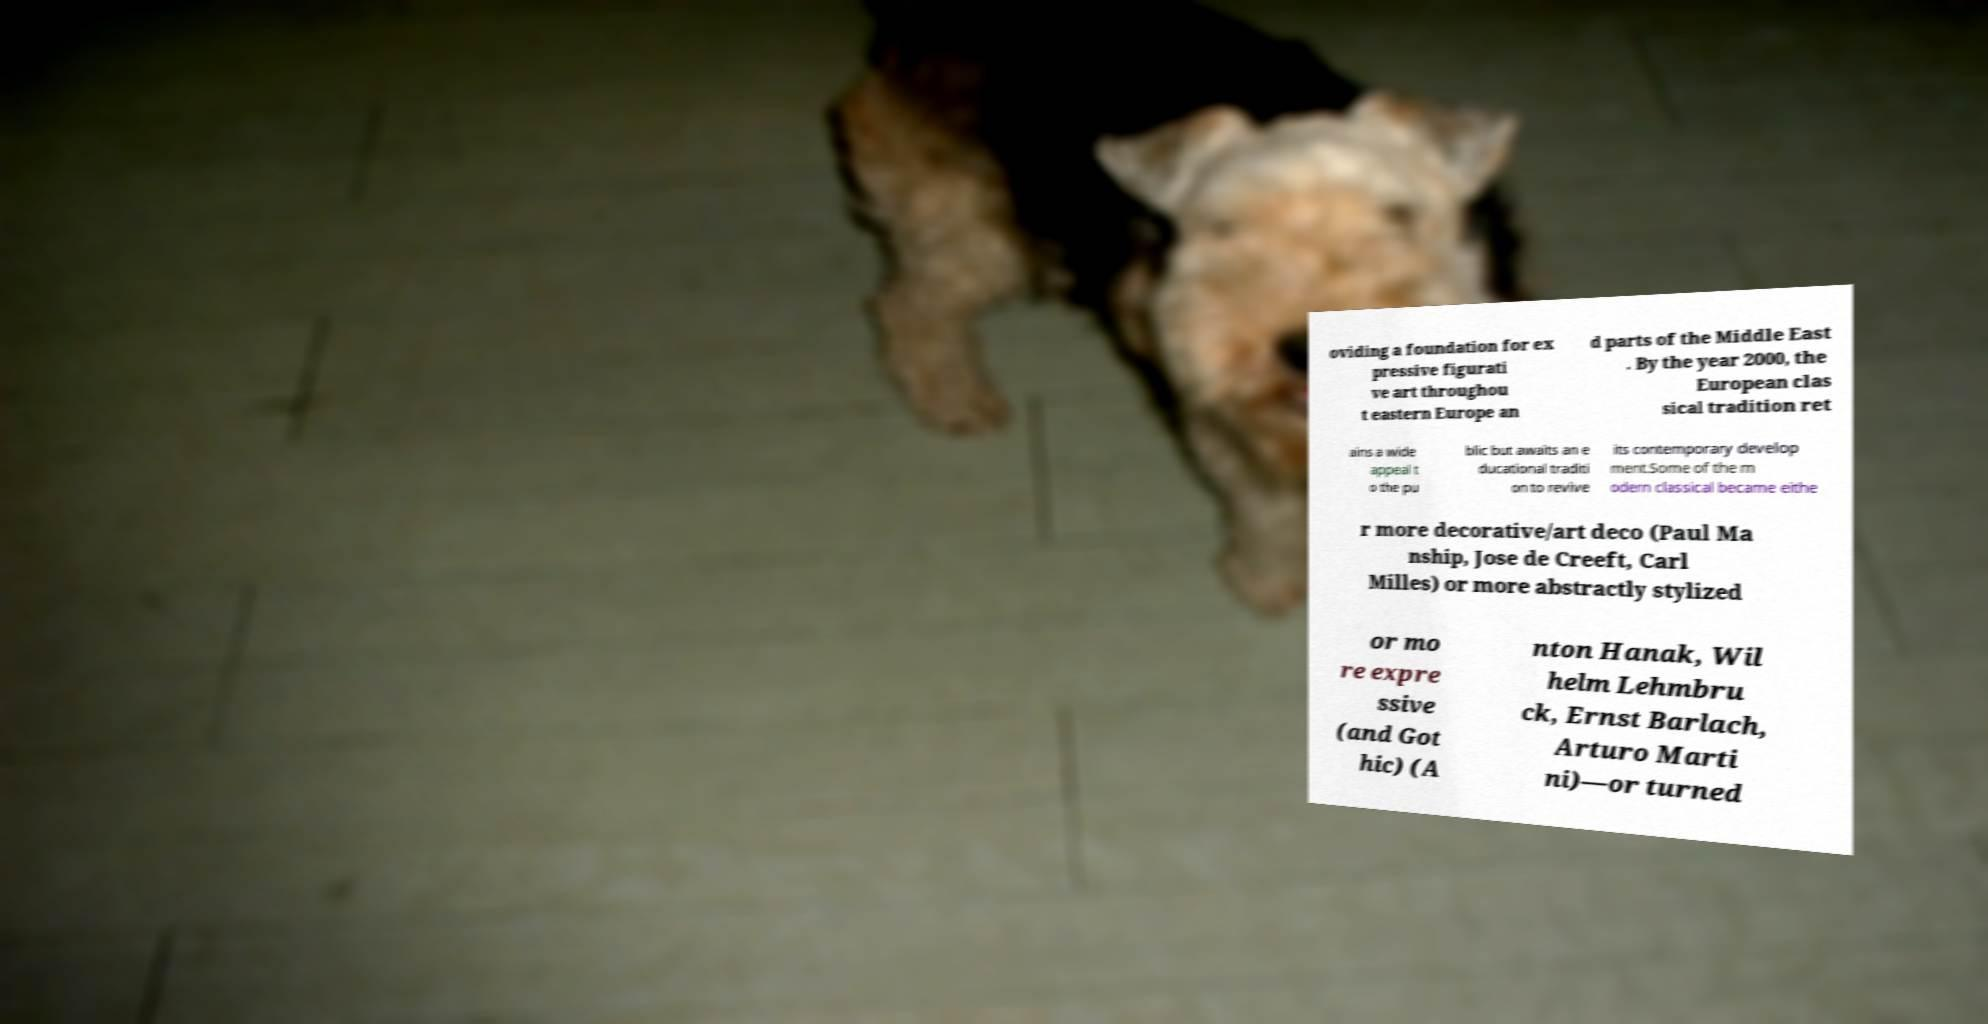For documentation purposes, I need the text within this image transcribed. Could you provide that? oviding a foundation for ex pressive figurati ve art throughou t eastern Europe an d parts of the Middle East . By the year 2000, the European clas sical tradition ret ains a wide appeal t o the pu blic but awaits an e ducational traditi on to revive its contemporary develop ment.Some of the m odern classical became eithe r more decorative/art deco (Paul Ma nship, Jose de Creeft, Carl Milles) or more abstractly stylized or mo re expre ssive (and Got hic) (A nton Hanak, Wil helm Lehmbru ck, Ernst Barlach, Arturo Marti ni)—or turned 